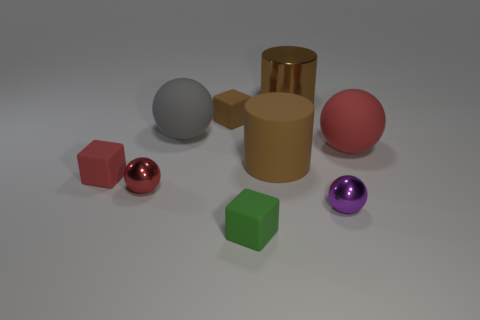Subtract all red cubes. How many cubes are left? 2 Add 1 tiny brown cylinders. How many objects exist? 10 Subtract all blue blocks. How many red spheres are left? 2 Subtract 1 blocks. How many blocks are left? 2 Subtract all red blocks. How many blocks are left? 2 Subtract all cylinders. How many objects are left? 7 Subtract all gray cubes. Subtract all red cylinders. How many cubes are left? 3 Subtract all tiny shiny objects. Subtract all purple shiny things. How many objects are left? 6 Add 8 tiny green things. How many tiny green things are left? 9 Add 8 tiny yellow rubber cubes. How many tiny yellow rubber cubes exist? 8 